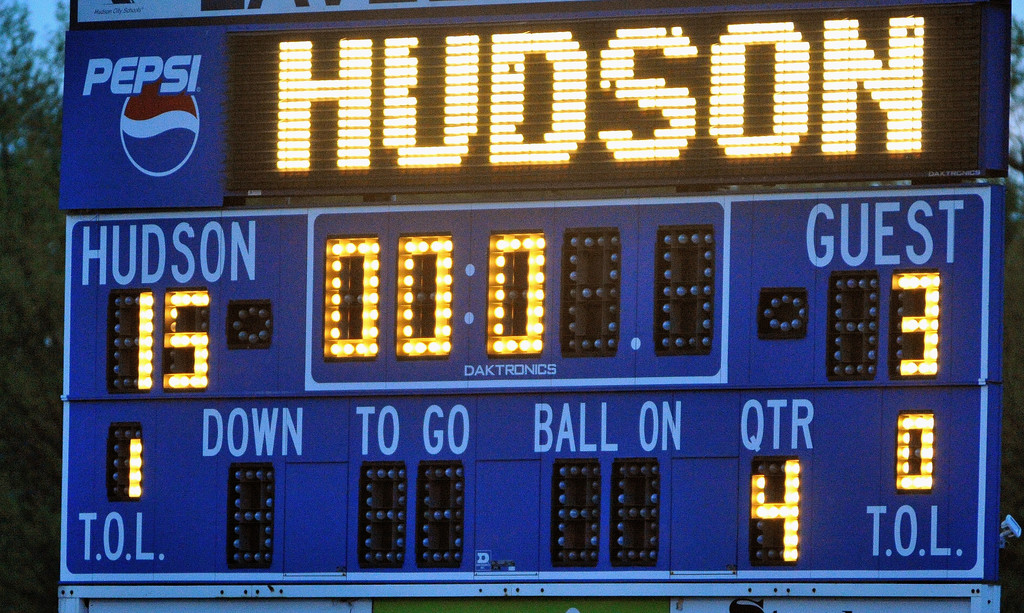What information does the scoreboard provide about the game's progress? The scoreboard shows that the game is in the fourth quarter, indicating the last part of the game. The 'down' and 'to go' sections are blank, signaling that play is likely paused, perhaps at the game's conclusion. The 'ball on' is similarly empty, and the guest team has no timeouts left, suggesting they used their resources to secure their win. 